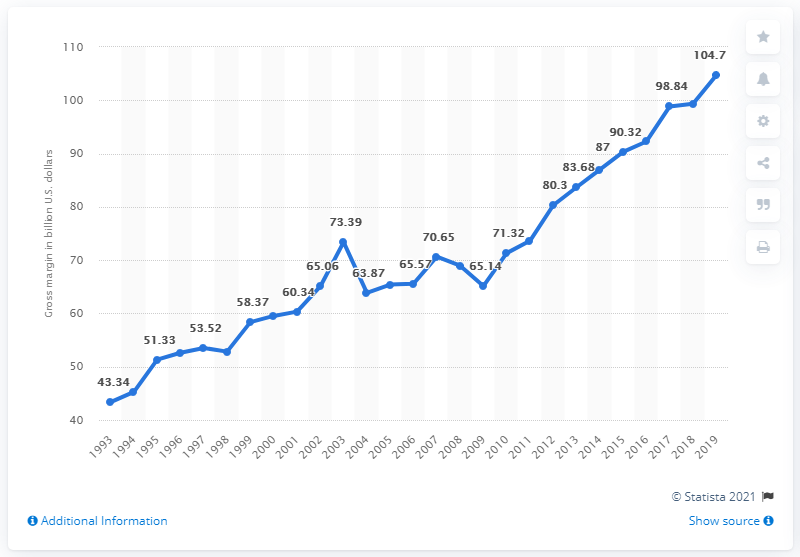Highlight a few significant elements in this photo. The gross margin on groceries and related products in U.S. wholesale in 2019 was 104.7%. 